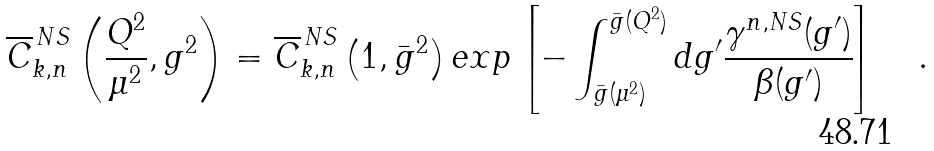<formula> <loc_0><loc_0><loc_500><loc_500>\overline { C } _ { k , n } ^ { \, N S } \left ( \frac { Q ^ { 2 } } { \mu ^ { 2 } } , g ^ { 2 } \right ) = \overline { C } _ { k , n } ^ { \, N S } \left ( 1 , \bar { g } ^ { 2 } \right ) e x p \left [ - \int _ { \bar { g } ( \mu ^ { 2 } ) } ^ { \bar { g } ( Q ^ { 2 } ) } d g ^ { \prime } \frac { \gamma ^ { n , N S } ( g ^ { \prime } ) } { \beta ( g ^ { \prime } ) } \right ] \quad .</formula> 